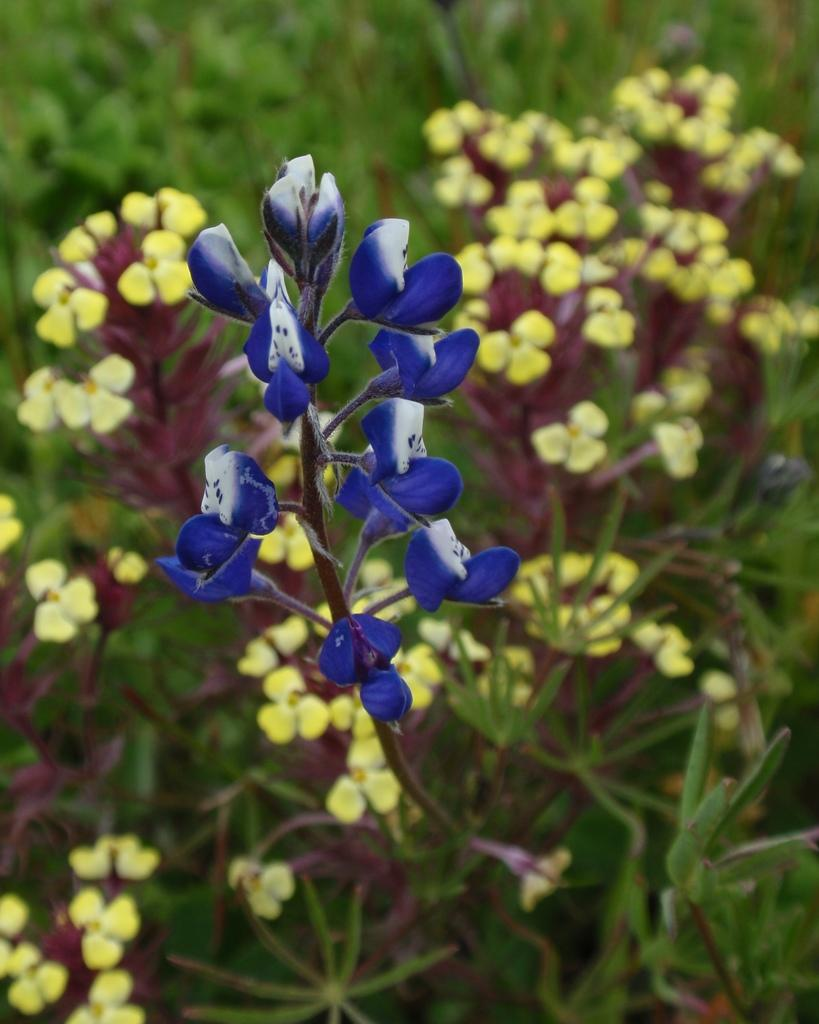What type of living organisms can be seen in the image? Plants can be seen in the image. What additional feature can be observed on the plants? The plants have flowers. How does the plant help someone in the bedroom in the image? There is no bedroom or indication of someone needing help in the image; it only features plants with flowers. What type of sugar is being used to sweeten the plant in the image? There is no sugar or indication of sweetening in the image; it only features plants with flowers. 